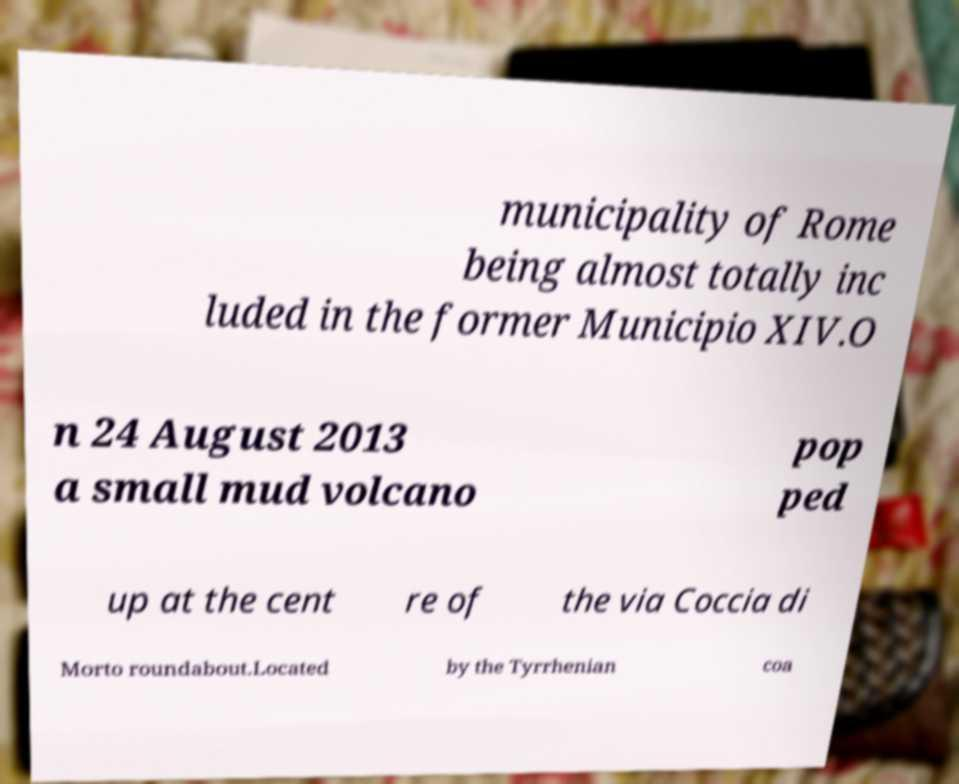There's text embedded in this image that I need extracted. Can you transcribe it verbatim? municipality of Rome being almost totally inc luded in the former Municipio XIV.O n 24 August 2013 a small mud volcano pop ped up at the cent re of the via Coccia di Morto roundabout.Located by the Tyrrhenian coa 